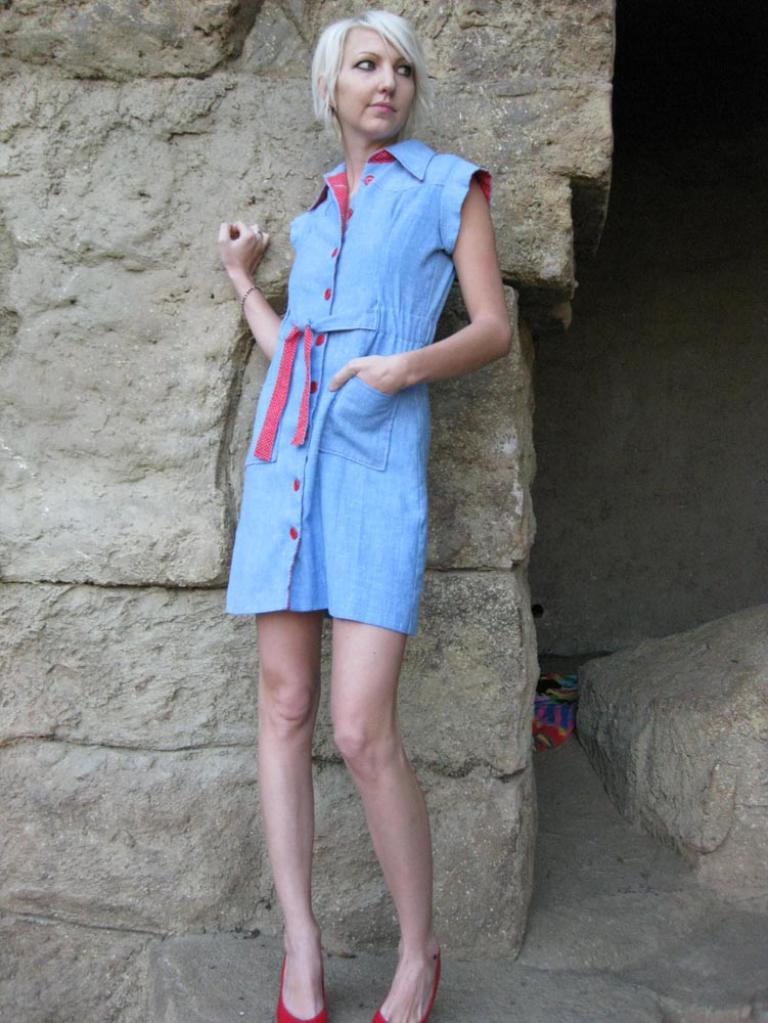Who is the main subject in the image? There is a woman in the image. What is the woman wearing? The woman is wearing a blue dress. Where is the woman positioned in the image? The woman is standing in the middle of the image. What can be seen in the background of the image? There is a wall in the background of the image. What type of connection can be seen on the woman's face in the image? There is no connection visible on the woman's face in the image. 